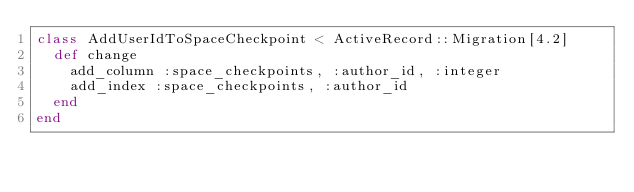Convert code to text. <code><loc_0><loc_0><loc_500><loc_500><_Ruby_>class AddUserIdToSpaceCheckpoint < ActiveRecord::Migration[4.2]
  def change
    add_column :space_checkpoints, :author_id, :integer
    add_index :space_checkpoints, :author_id
  end
end
</code> 